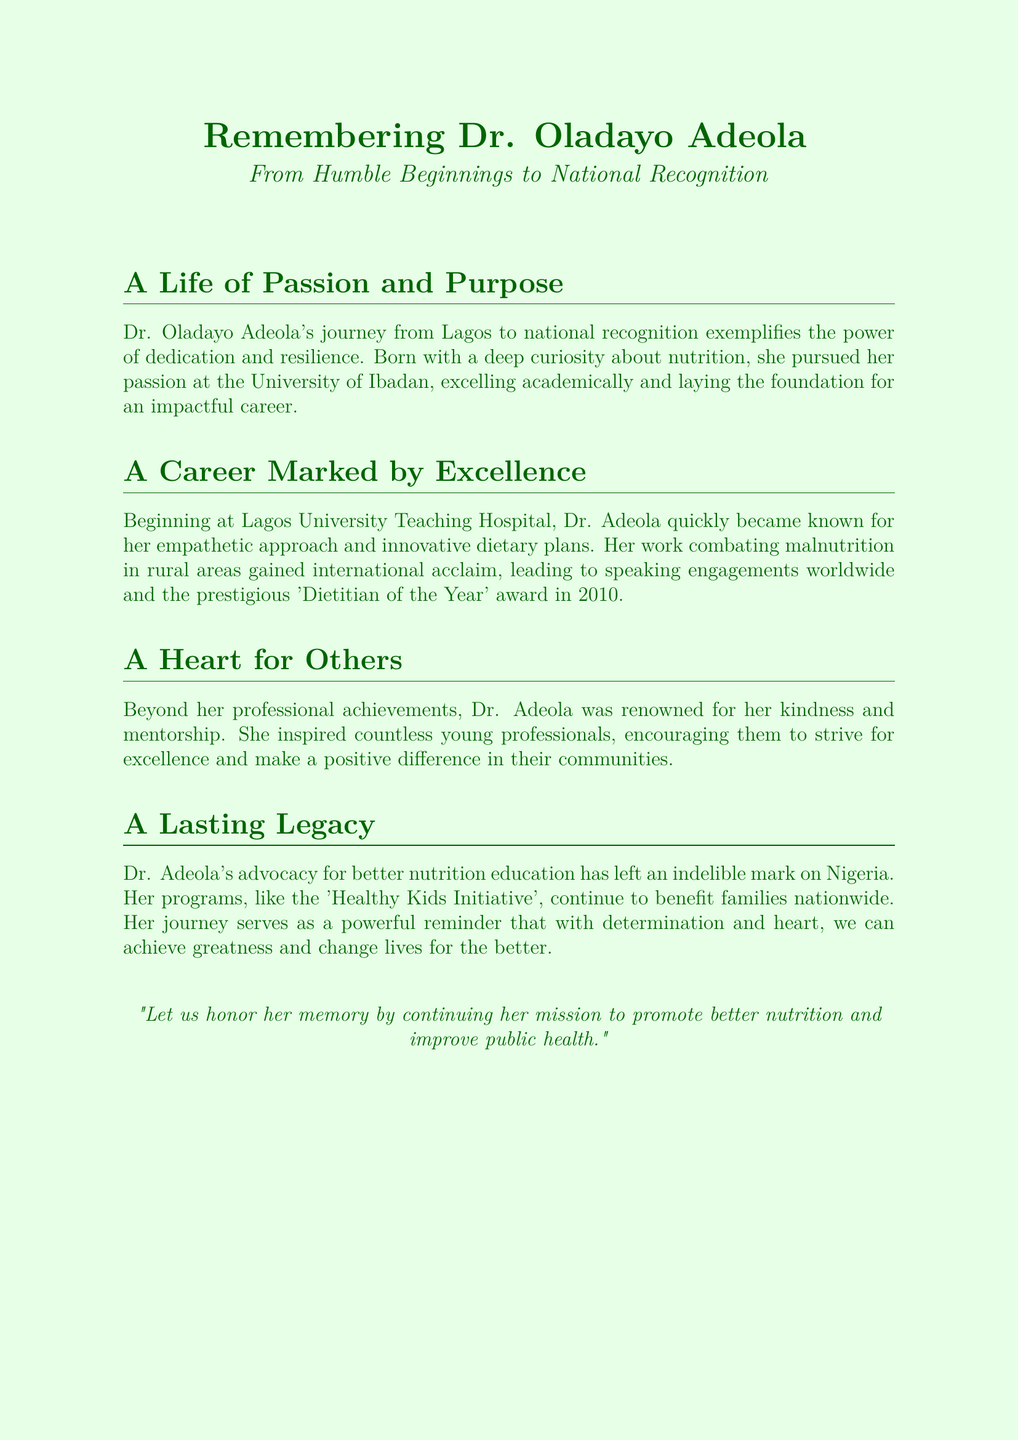What is the name of the dietitian being remembered? The document is a eulogy for Dr. Oladayo Adeola, highlighting her life and contributions.
Answer: Dr. Oladayo Adeola Where was Dr. Adeola born? The document states that she was born in Lagos, indicating her origins before her recognition.
Answer: Lagos What award did Dr. Adeola receive in 2010? The eulogy notes that she was honored with the 'Dietitian of the Year' award in 2010.
Answer: Dietitian of the Year What was one of Dr. Adeola’s notable programs? The program mentioned in the eulogy that continues to benefit families is the 'Healthy Kids Initiative'.
Answer: Healthy Kids Initiative What profession did Dr. Adeola excel in? The document specifies her profession as a dietitian, emphasizing her area of expertise.
Answer: Dietitian What institution did Dr. Adeola begin her career at? The eulogy mentions that she started her career at Lagos University Teaching Hospital.
Answer: Lagos University Teaching Hospital What quality was Dr. Adeola known for in her approach? The document indicates that she was recognized for her empathetic approach in her professional work.
Answer: Empathetic What was a key focus of Dr. Adeola’s work? The eulogy highlights her work in combating malnutrition, particularly in rural areas.
Answer: Combating malnutrition What is the main message of the document? The eulogy emphasizes honoring Dr. Adeola’s memory by promoting better nutrition and improving public health.
Answer: Promote better nutrition and improve public health 